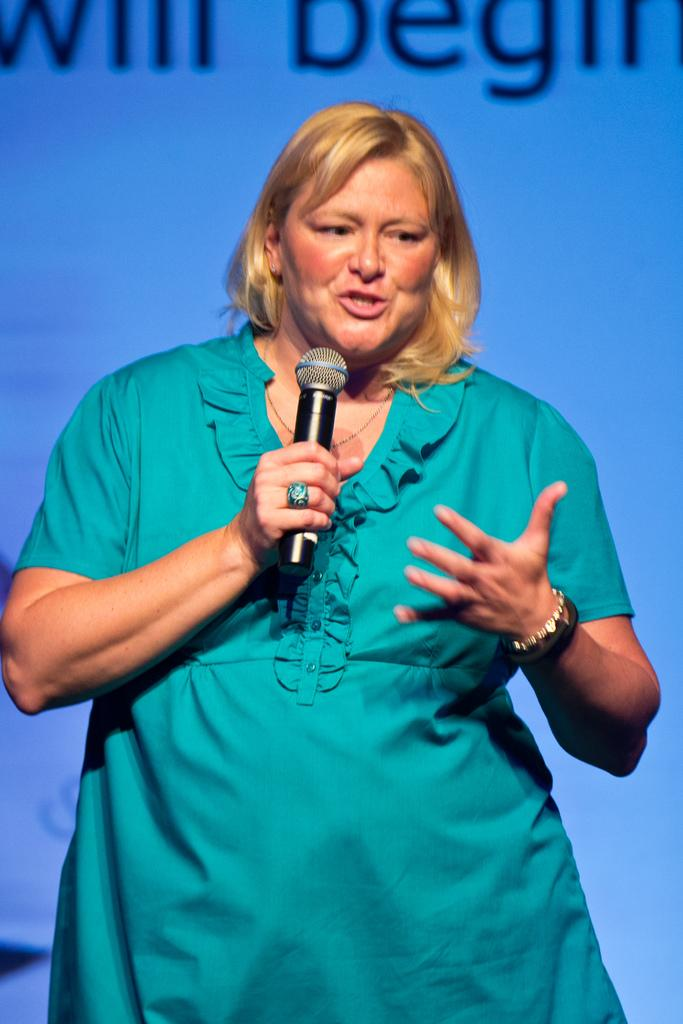Who is the main subject in the image? There is a woman in the image. Where is the woman located? The woman is standing on a stage. What is the woman holding in her hand? The woman is holding a mic in her hand. What is the woman doing in the image? The woman is talking. What can be seen in the background of the image? There is a poster with text in the background of the image. Can you see any ocean waves in the image? There is no ocean or waves present in the image. What type of tray is the woman using to hold the mic? The woman is not using a tray to hold the mic; she is holding it directly in her hand. 